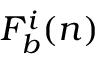Convert formula to latex. <formula><loc_0><loc_0><loc_500><loc_500>F _ { b } ^ { i } ( n )</formula> 